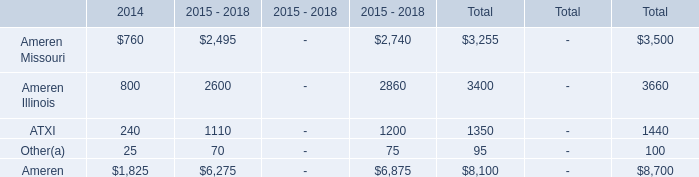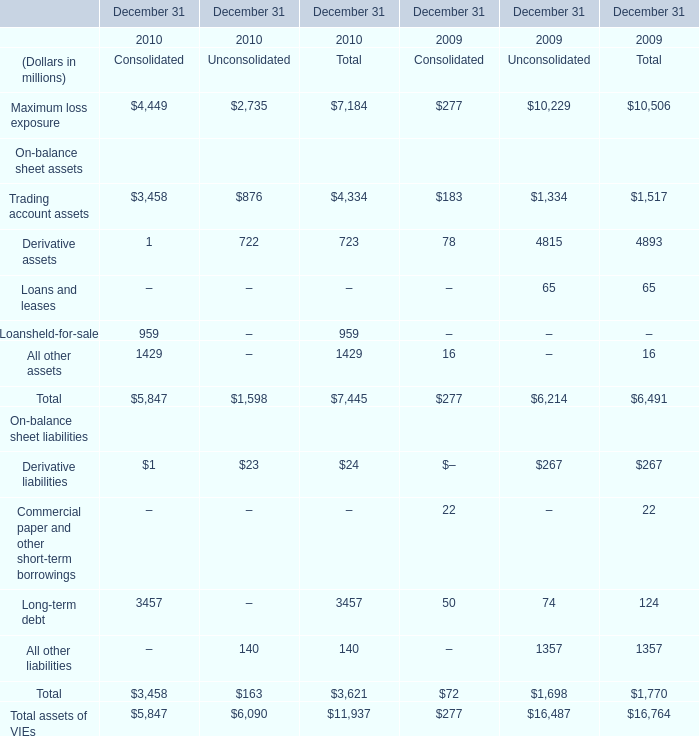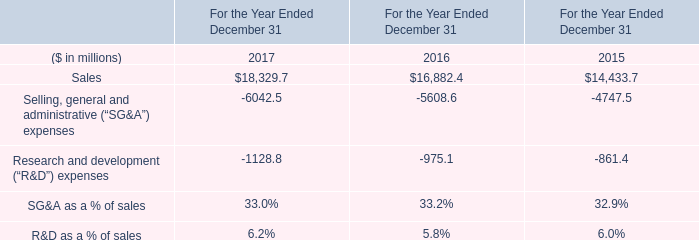What's the average of total assets of VIEs totally in 2010 and 2009? (in dollars in millions) 
Computations: ((11937 + 16764) / 2)
Answer: 14350.5. 